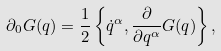Convert formula to latex. <formula><loc_0><loc_0><loc_500><loc_500>\partial _ { 0 } G ( q ) = \frac { 1 } { 2 } \left \{ \dot { q } ^ { \alpha } , \frac { \partial } { \partial q ^ { \alpha } } G ( q ) \right \} ,</formula> 